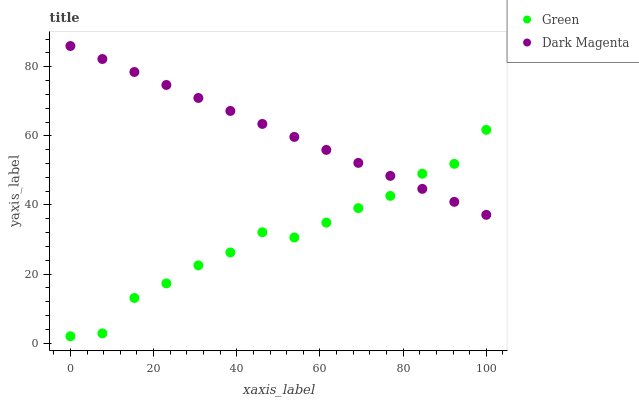Does Green have the minimum area under the curve?
Answer yes or no. Yes. Does Dark Magenta have the maximum area under the curve?
Answer yes or no. Yes. Does Dark Magenta have the minimum area under the curve?
Answer yes or no. No. Is Dark Magenta the smoothest?
Answer yes or no. Yes. Is Green the roughest?
Answer yes or no. Yes. Is Dark Magenta the roughest?
Answer yes or no. No. Does Green have the lowest value?
Answer yes or no. Yes. Does Dark Magenta have the lowest value?
Answer yes or no. No. Does Dark Magenta have the highest value?
Answer yes or no. Yes. Does Dark Magenta intersect Green?
Answer yes or no. Yes. Is Dark Magenta less than Green?
Answer yes or no. No. Is Dark Magenta greater than Green?
Answer yes or no. No. 